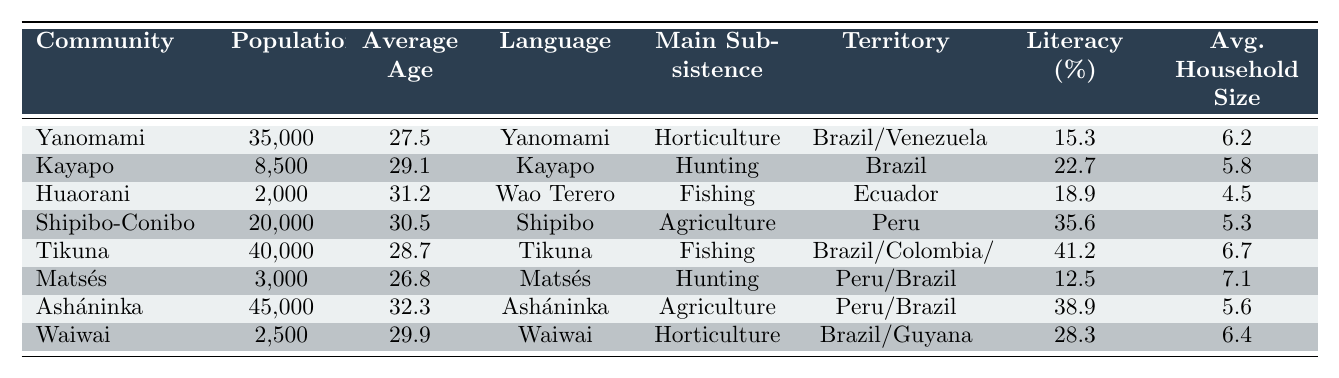What is the average age of the Yanomami community? The table lists the Yanomami community with an average age of 27.5 years.
Answer: 27.5 Which community has the highest percentage of literacy? In the table, the Asháninka community has the highest literacy percentage at 38.9%.
Answer: Asháninka What is the total population of the Kayapo and Matsés communities combined? The population of Kayapo is 8,500 and Matsés is 3,000. Adding them together gives 8,500 + 3,000 = 11,500.
Answer: 11,500 Which community primarily relies on agriculture for subsistence? The Shipibo-Conibo and Asháninka communities both depend on agriculture.
Answer: Shipibo-Conibo and Asháninka Is the average household size for the Huaorani community greater than 5? The table shows the average household size for Huaorani is 4.5, which is less than 5. Hence, the statement is false.
Answer: No What is the median average age of the communities listed? The average ages, sorted are: 26.8, 27.5, 28.7, 29.1, 30.5, 31.2, 32.3. The median, being the middle value of 7 data points, is the average of the 3rd and 4th values: (29.1 + 30.5)/2 = 29.8.
Answer: 29.8 Which community has the largest average household size and what is that size? According to the table, Matsés has the largest average household size at 7.1.
Answer: Matsés, 7.1 How does the literacy rate of the Tikuna community compare to the average literacy rate of all communities? Tikuna's literacy rate is 41.2%. Adding all literacy percentages: (15.3 + 22.7 + 18.9 + 35.6 + 41.2 + 12.5 + 38.9 + 28.3) = 173.4, then average is 173.4/8 = 21.675%. Since 41.2 is higher than the average, Tikuna's literacy rate is above average.
Answer: Yes What is the average age of the two communities that primarily rely on fishing? The two communities that rely on fishing are Huaorani (31.2 years) and Tikuna (28.7 years). Their average age is (31.2 + 28.7)/2 = 29.95.
Answer: 29.95 Which community has the smallest population and what is the size? The Matsés community has the smallest population at 3,000.
Answer: Matsés, 3,000 